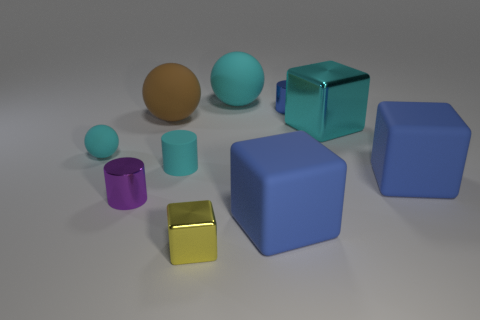Subtract all blocks. How many objects are left? 6 Add 3 metal objects. How many metal objects are left? 7 Add 4 tiny cyan objects. How many tiny cyan objects exist? 6 Subtract 1 brown balls. How many objects are left? 9 Subtract all large matte cubes. Subtract all cyan cubes. How many objects are left? 7 